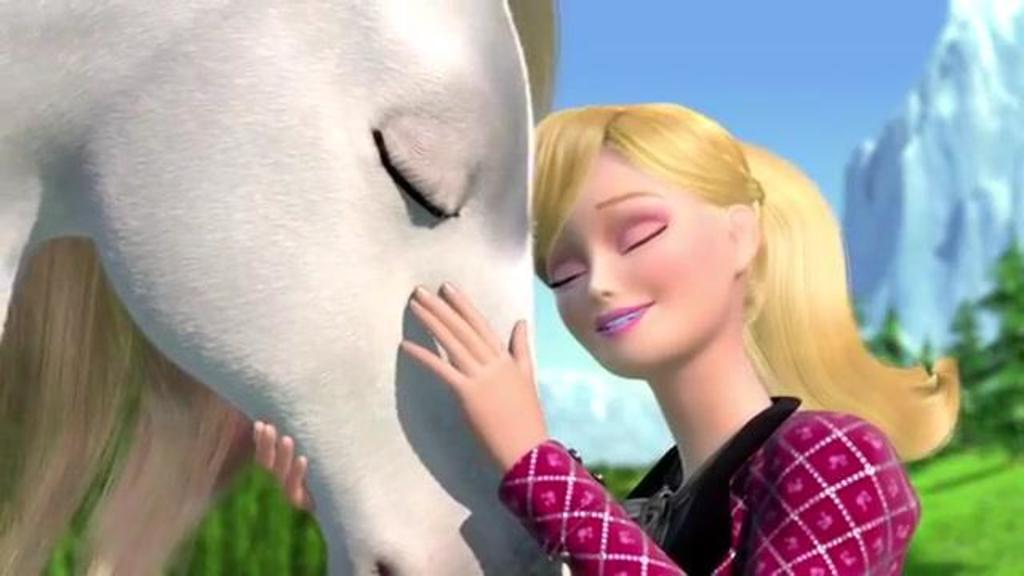Who is present in the image? There is a woman in the image. What is the woman holding in the image? The woman is holding a horse head. What can be seen in the background of the image? There is sky, mountains, and trees visible in the background of the image. What type of tooth is visible in the image? There is no tooth visible in the image. Is the woman using a rifle in the image? There is no rifle present in the image. 